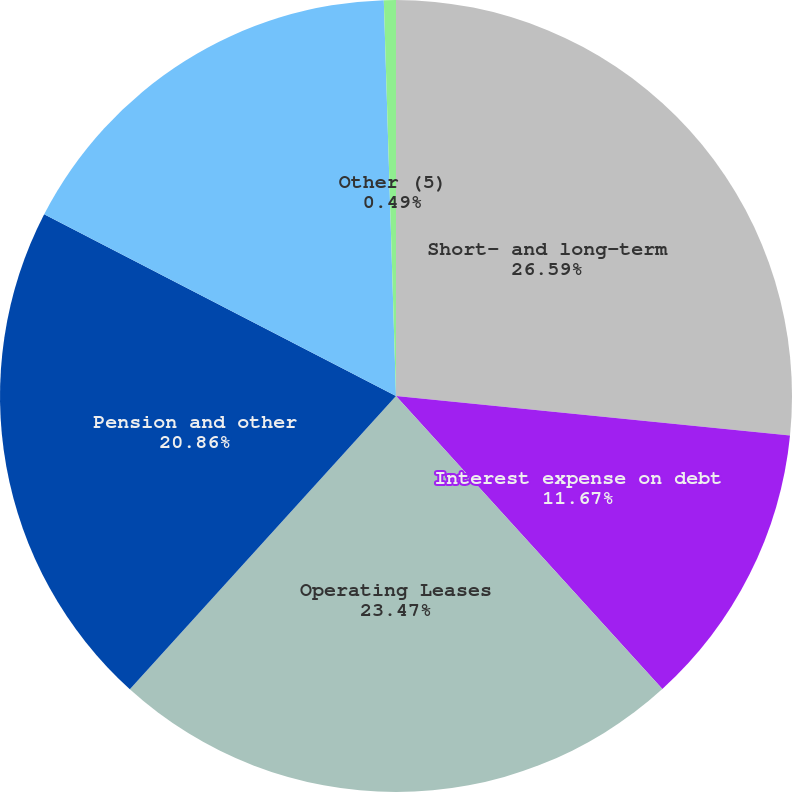Convert chart. <chart><loc_0><loc_0><loc_500><loc_500><pie_chart><fcel>Short- and long-term<fcel>Interest expense on debt<fcel>Operating Leases<fcel>Pension and other<fcel>Purchase obligations (3) (4)<fcel>Other (5)<nl><fcel>26.59%<fcel>11.67%<fcel>23.47%<fcel>20.86%<fcel>16.92%<fcel>0.49%<nl></chart> 